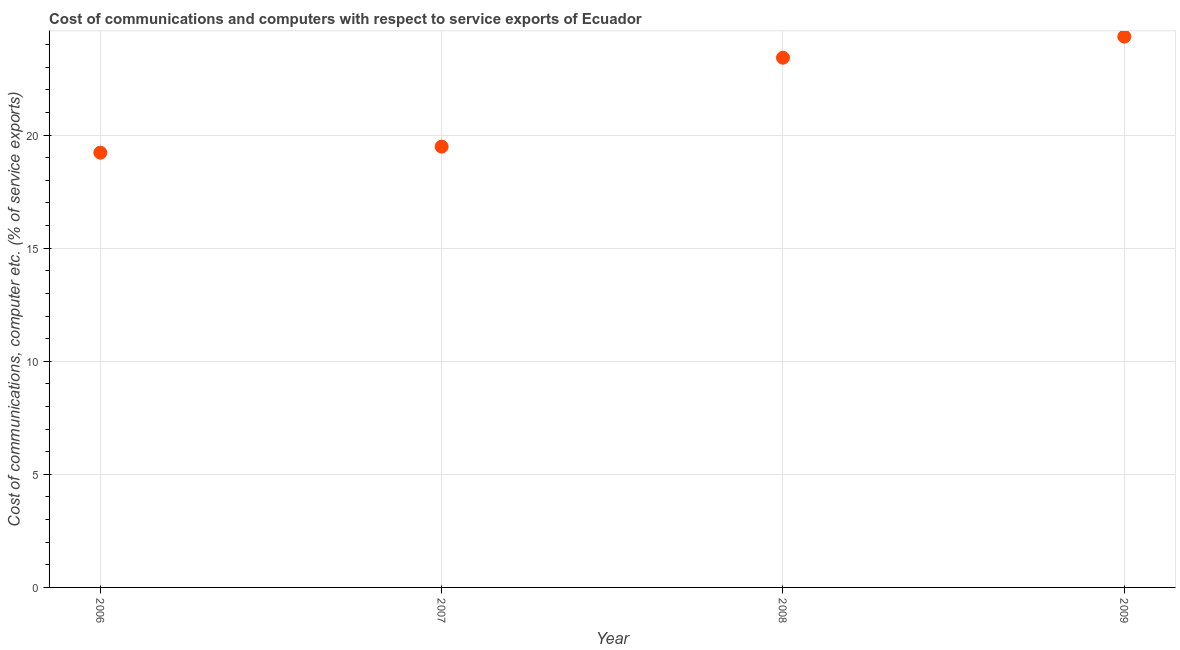What is the cost of communications and computer in 2007?
Keep it short and to the point. 19.49. Across all years, what is the maximum cost of communications and computer?
Your response must be concise. 24.35. Across all years, what is the minimum cost of communications and computer?
Offer a terse response. 19.22. In which year was the cost of communications and computer maximum?
Provide a succinct answer. 2009. In which year was the cost of communications and computer minimum?
Your answer should be compact. 2006. What is the sum of the cost of communications and computer?
Your answer should be compact. 86.48. What is the difference between the cost of communications and computer in 2006 and 2007?
Offer a terse response. -0.27. What is the average cost of communications and computer per year?
Provide a succinct answer. 21.62. What is the median cost of communications and computer?
Ensure brevity in your answer.  21.45. Do a majority of the years between 2009 and 2006 (inclusive) have cost of communications and computer greater than 10 %?
Offer a very short reply. Yes. What is the ratio of the cost of communications and computer in 2006 to that in 2007?
Keep it short and to the point. 0.99. What is the difference between the highest and the second highest cost of communications and computer?
Your response must be concise. 0.93. What is the difference between the highest and the lowest cost of communications and computer?
Provide a succinct answer. 5.13. How many dotlines are there?
Your answer should be compact. 1. How many years are there in the graph?
Give a very brief answer. 4. Does the graph contain any zero values?
Your answer should be compact. No. Does the graph contain grids?
Your answer should be compact. Yes. What is the title of the graph?
Ensure brevity in your answer.  Cost of communications and computers with respect to service exports of Ecuador. What is the label or title of the X-axis?
Your answer should be very brief. Year. What is the label or title of the Y-axis?
Make the answer very short. Cost of communications, computer etc. (% of service exports). What is the Cost of communications, computer etc. (% of service exports) in 2006?
Offer a terse response. 19.22. What is the Cost of communications, computer etc. (% of service exports) in 2007?
Ensure brevity in your answer.  19.49. What is the Cost of communications, computer etc. (% of service exports) in 2008?
Keep it short and to the point. 23.42. What is the Cost of communications, computer etc. (% of service exports) in 2009?
Offer a terse response. 24.35. What is the difference between the Cost of communications, computer etc. (% of service exports) in 2006 and 2007?
Make the answer very short. -0.27. What is the difference between the Cost of communications, computer etc. (% of service exports) in 2006 and 2008?
Your answer should be very brief. -4.2. What is the difference between the Cost of communications, computer etc. (% of service exports) in 2006 and 2009?
Keep it short and to the point. -5.13. What is the difference between the Cost of communications, computer etc. (% of service exports) in 2007 and 2008?
Make the answer very short. -3.93. What is the difference between the Cost of communications, computer etc. (% of service exports) in 2007 and 2009?
Make the answer very short. -4.86. What is the difference between the Cost of communications, computer etc. (% of service exports) in 2008 and 2009?
Your answer should be compact. -0.93. What is the ratio of the Cost of communications, computer etc. (% of service exports) in 2006 to that in 2007?
Offer a terse response. 0.99. What is the ratio of the Cost of communications, computer etc. (% of service exports) in 2006 to that in 2008?
Ensure brevity in your answer.  0.82. What is the ratio of the Cost of communications, computer etc. (% of service exports) in 2006 to that in 2009?
Your answer should be very brief. 0.79. What is the ratio of the Cost of communications, computer etc. (% of service exports) in 2007 to that in 2008?
Provide a short and direct response. 0.83. 